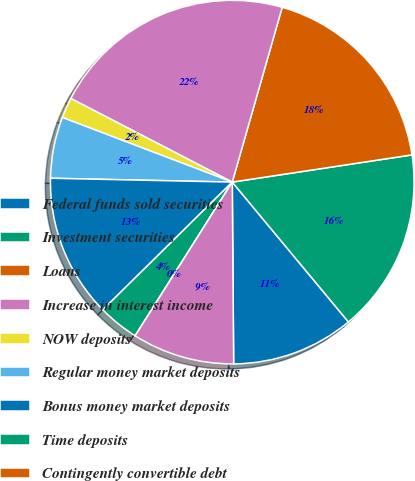Convert chart to OTSL. <chart><loc_0><loc_0><loc_500><loc_500><pie_chart><fcel>Federal funds sold securities<fcel>Investment securities<fcel>Loans<fcel>Increase in interest income<fcel>NOW deposits<fcel>Regular money market deposits<fcel>Bonus money market deposits<fcel>Time deposits<fcel>Contingently convertible debt<fcel>Junior subordinated debentures<nl><fcel>10.91%<fcel>16.36%<fcel>18.18%<fcel>21.82%<fcel>1.82%<fcel>5.45%<fcel>12.73%<fcel>3.64%<fcel>0.0%<fcel>9.09%<nl></chart> 